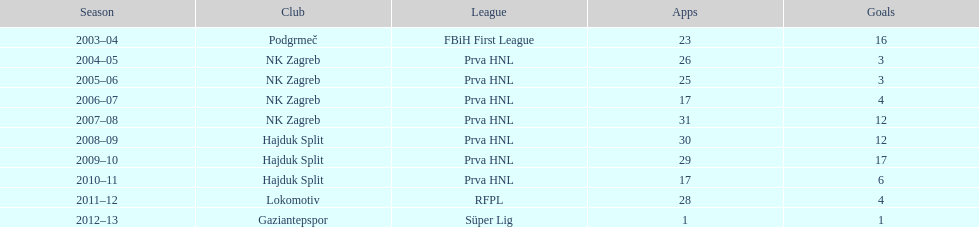After scoring against bulgaria in zenica, ibricic also scored against this team in a 7-0 victory in zenica less then a month after the friendly match against bulgaria. Estonia. 